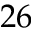Convert formula to latex. <formula><loc_0><loc_0><loc_500><loc_500>2 6</formula> 